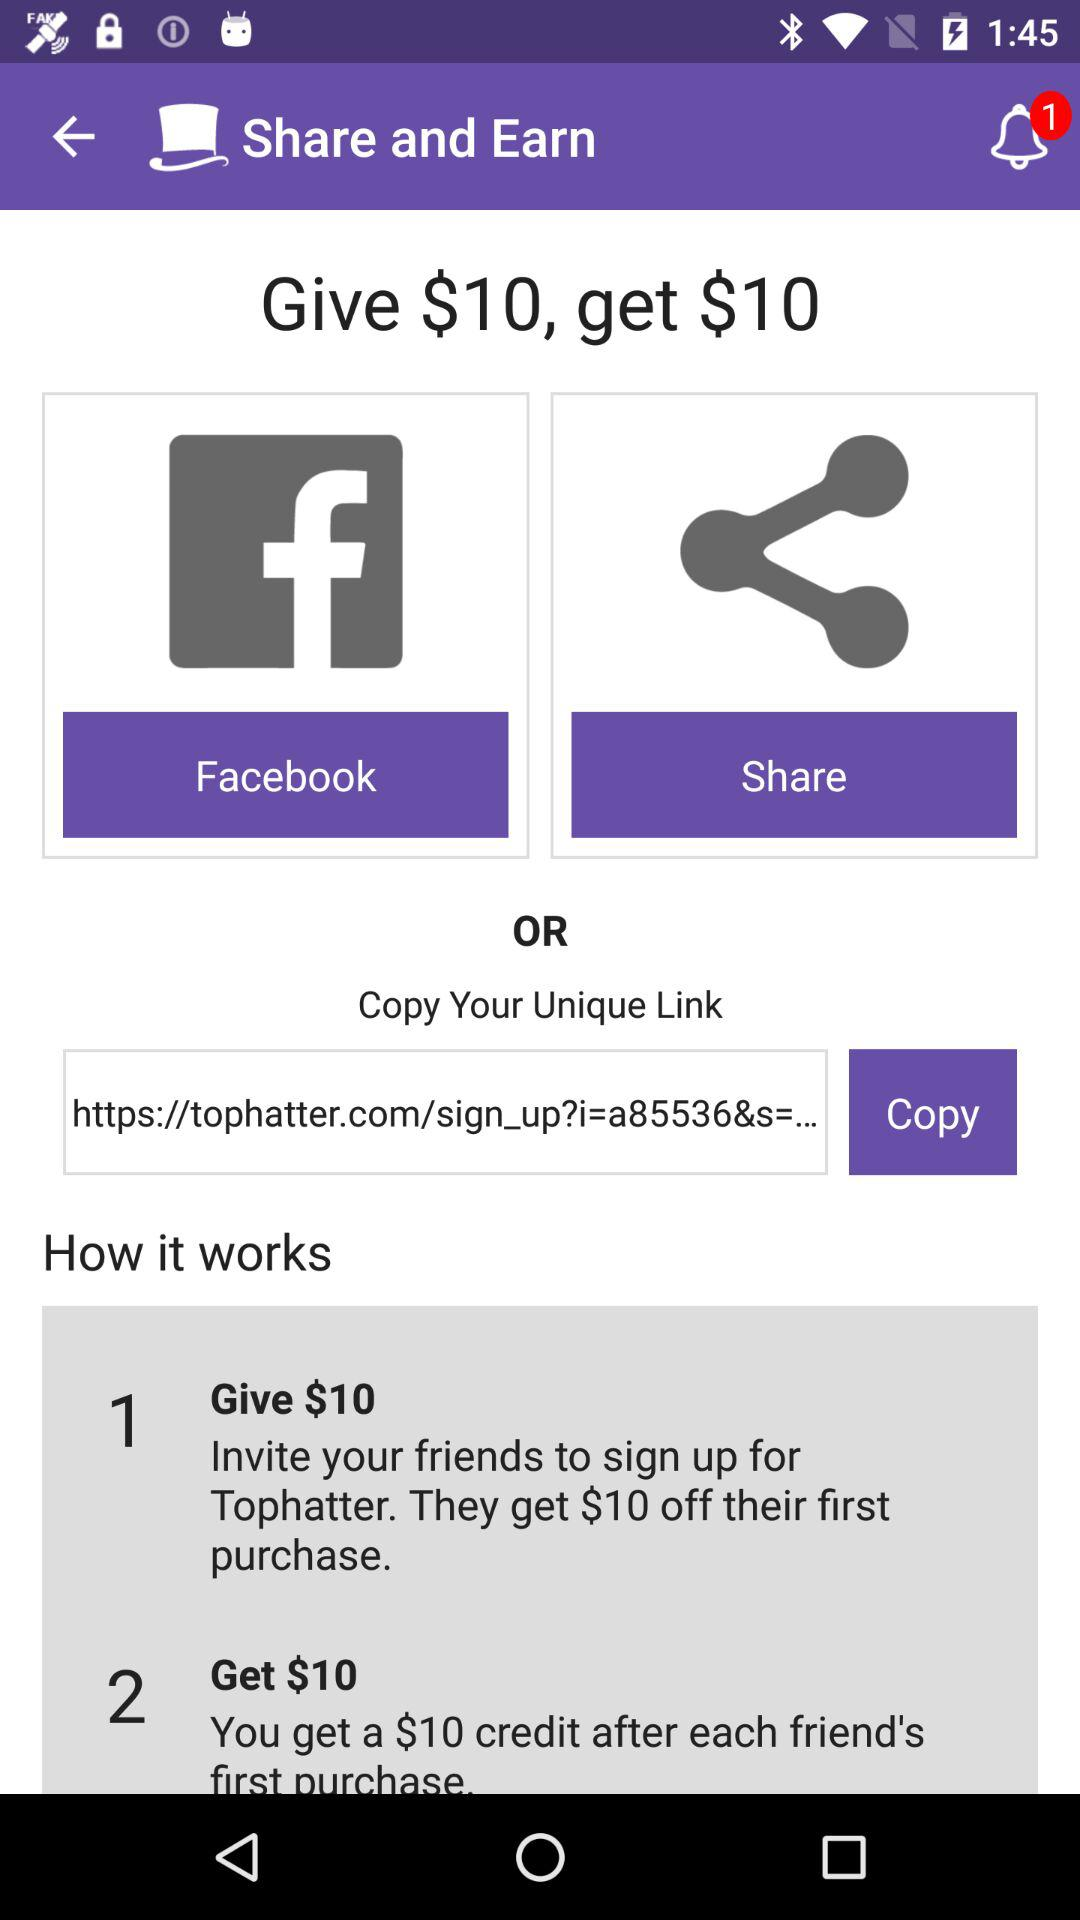How many notifications are unread? There is 1 unread notification. 